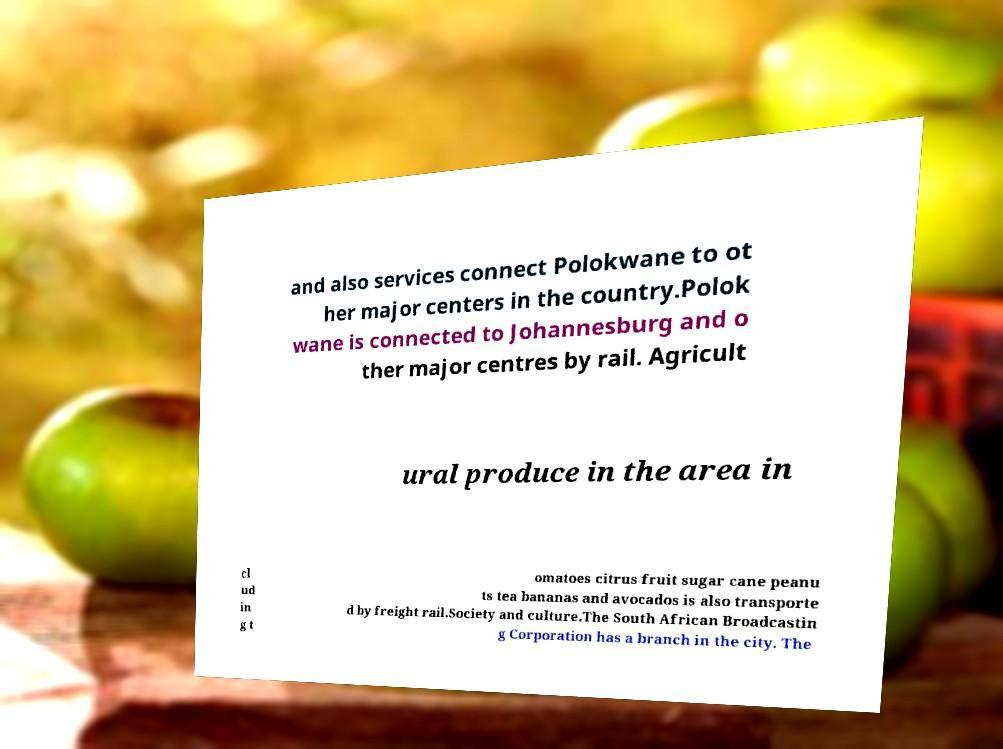Please read and relay the text visible in this image. What does it say? and also services connect Polokwane to ot her major centers in the country.Polok wane is connected to Johannesburg and o ther major centres by rail. Agricult ural produce in the area in cl ud in g t omatoes citrus fruit sugar cane peanu ts tea bananas and avocados is also transporte d by freight rail.Society and culture.The South African Broadcastin g Corporation has a branch in the city. The 